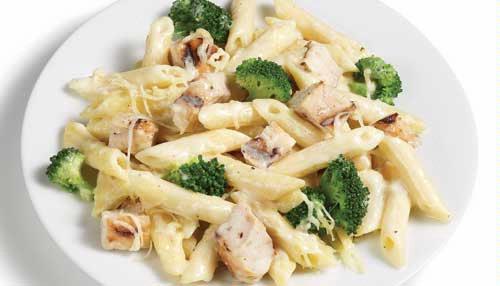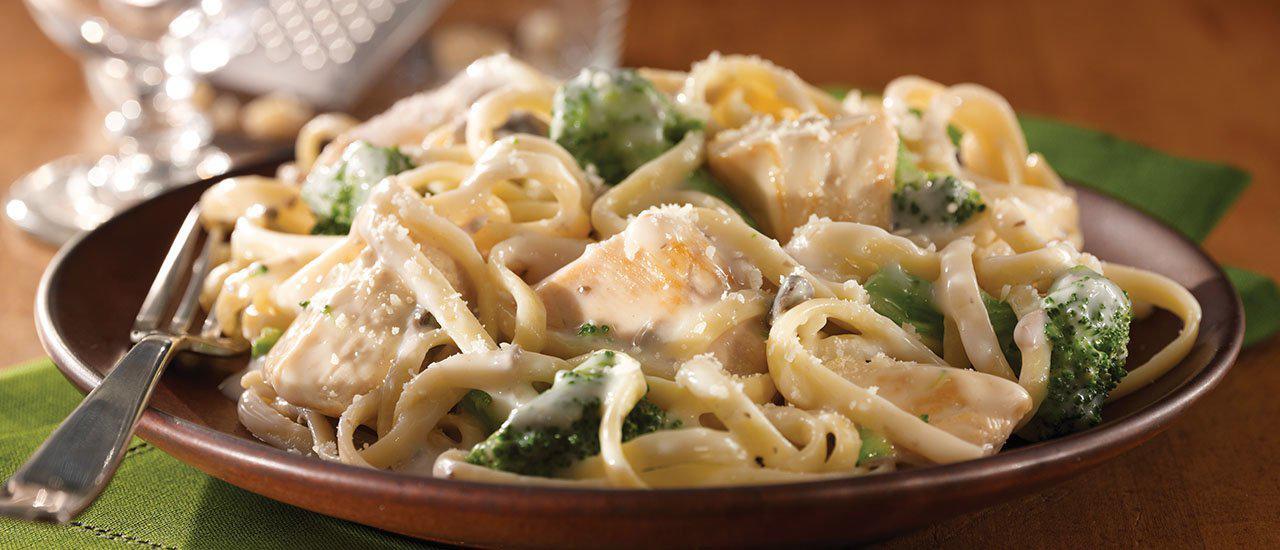The first image is the image on the left, the second image is the image on the right. Evaluate the accuracy of this statement regarding the images: "One image shows a pasta dish served in a mahogany colored bowl.". Is it true? Answer yes or no. Yes. 